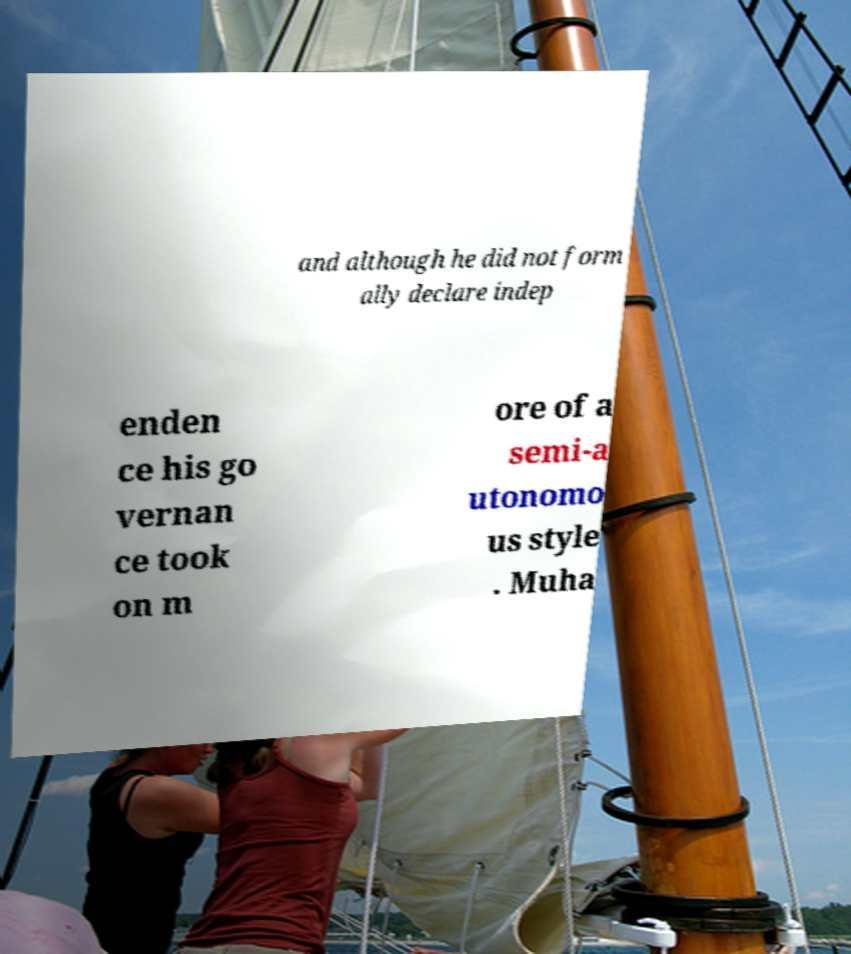Can you accurately transcribe the text from the provided image for me? and although he did not form ally declare indep enden ce his go vernan ce took on m ore of a semi-a utonomo us style . Muha 